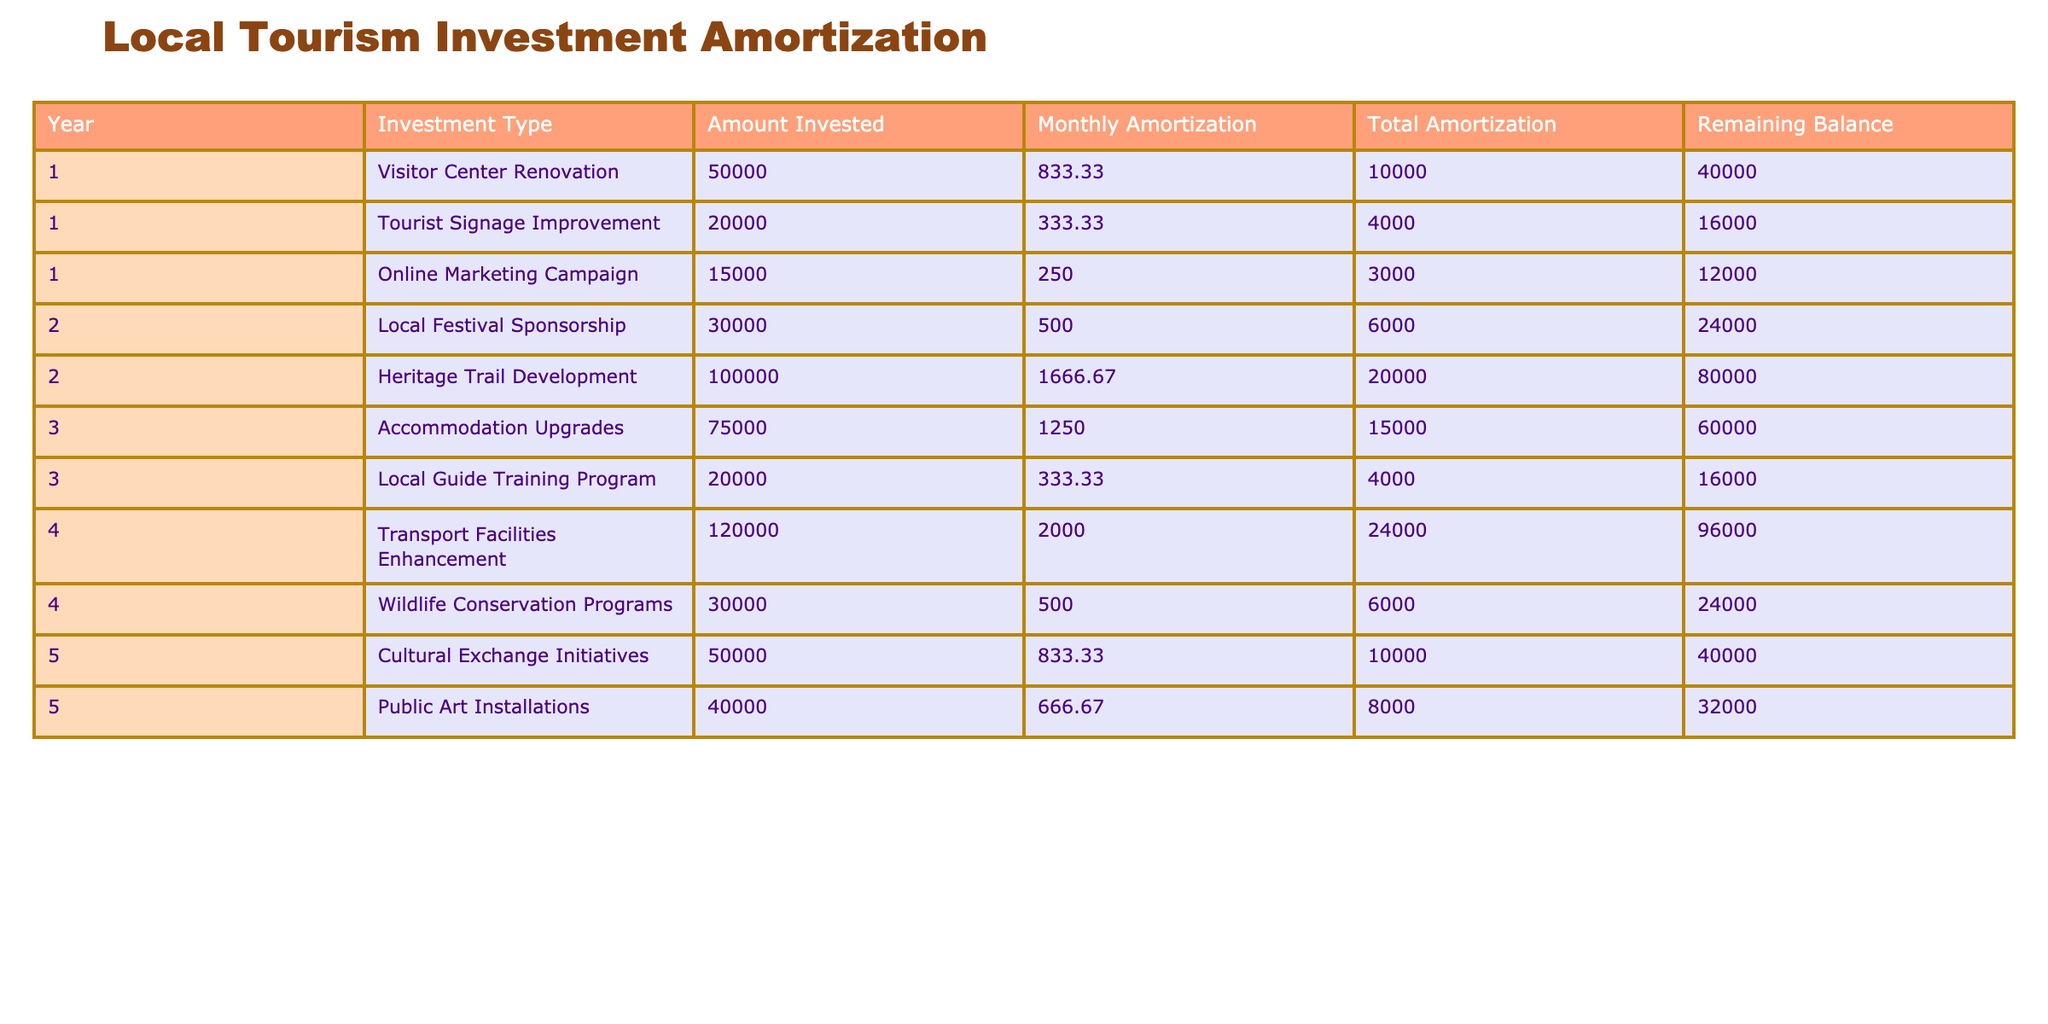What is the total amount invested in the first year? The first-year investments are: Visitor Center Renovation (50,000), Tourist Signage Improvement (20,000), and Online Marketing Campaign (15,000). Adding these amounts gives: 50,000 + 20,000 + 15,000 = 85,000.
Answer: 85,000 How much is the monthly amortization for the Heritage Trail Development? From the table, the monthly amortization listed for the Heritage Trail Development is 1,666.67.
Answer: 1,666.67 Which investment type has the highest total amortization amount after 5 years? Looking at the total amortization amounts for each investment: Visitor Center Renovation (10,000), Tourist Signage Improvement (4,000), Online Marketing Campaign (3,000), Local Festival Sponsorship (6,000), Heritage Trail Development (20,000), Accommodation Upgrades (15,000), Local Guide Training Program (4,000), Transport Facilities Enhancement (24,000), Wildlife Conservation Programs (6,000), Cultural Exchange Initiatives (10,000), and Public Art Installations (8,000). The highest is Transport Facilities Enhancement at 24,000.
Answer: Transport Facilities Enhancement What is the remaining balance after the second year for the Local Festival Sponsorship? The remaining balance for the Local Festival Sponsorship after the second year is listed as 24,000.
Answer: 24,000 Is the total amortization for the Wildlife Conservation Programs equal to 6,000? The total amortization for the Wildlife Conservation Programs is explicitly given in the table as 6,000, confirming that this statement is true.
Answer: Yes What is the average remaining balance after each year? The total remaining balances at the end of each year are: 40,000 (Year 1), 16,000 (Year 1), and so on till Year 5. Adding them gives a total of 40,000 + 16,000 + 60,000 + 96,000 + 40,000 + 32,000 = 284,000. There are 5 years, so the average remaining balance is 284,000 / 5 = 56,800.
Answer: 56,800 How much total investment was made in 2023? In 2023, there are two investments: Cultural Exchange Initiatives (50,000) and Public Art Installations (40,000) amounting to 50,000 + 40,000 = 90,000.
Answer: 90,000 Which year saw the highest amount of monthly amortization across investments? The monthly amortizations for each year are: Year 1 (1,416.66), Year 2 (2,166.67), Year 3 (1,583.33), Year 4 (2,500.00), and Year 5 (1,500.00). The highest is recorded in Year 4 with 2,500.00.
Answer: Year 4 